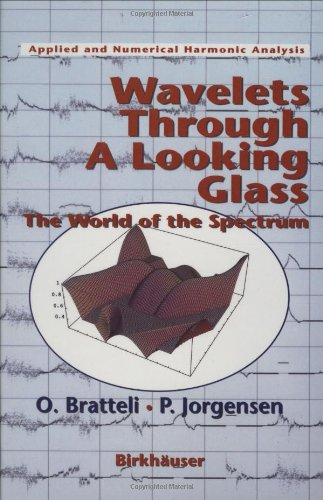How does this book contribute to the field of numerical harmonic analysis? The book 'Wavelets Through a Looking Glass' makes a significant contribution by bridging theoretical insights with practical applications in numerical harmonic analysis. It explains the use of wavelets in simplifying complex data sets thereby expanding on their utility in real-world analyses and problem-solving scenarios. 